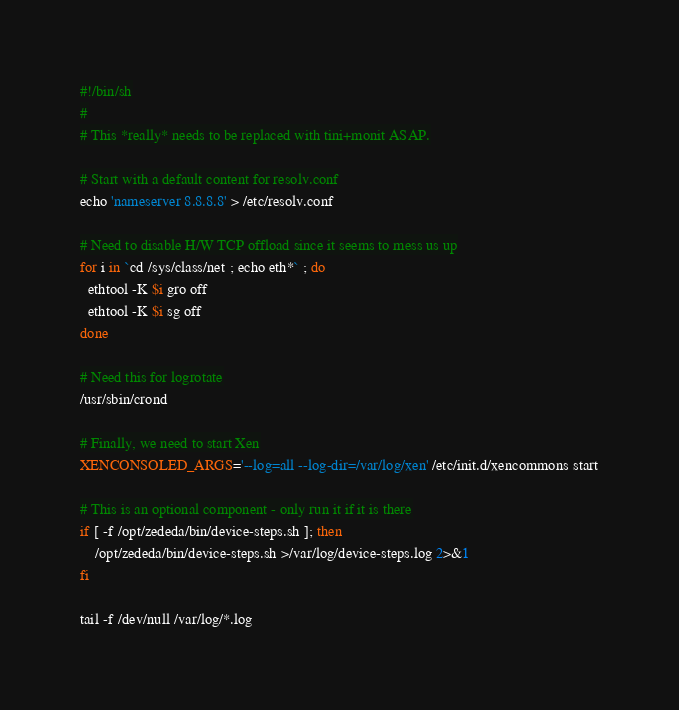<code> <loc_0><loc_0><loc_500><loc_500><_Bash_>#!/bin/sh
#
# This *really* needs to be replaced with tini+monit ASAP.

# Start with a default content for resolv.conf
echo 'nameserver 8.8.8.8' > /etc/resolv.conf

# Need to disable H/W TCP offload since it seems to mess us up
for i in `cd /sys/class/net ; echo eth*` ; do
  ethtool -K $i gro off
  ethtool -K $i sg off
done

# Need this for logrotate
/usr/sbin/crond

# Finally, we need to start Xen
XENCONSOLED_ARGS='--log=all --log-dir=/var/log/xen' /etc/init.d/xencommons start

# This is an optional component - only run it if it is there
if [ -f /opt/zededa/bin/device-steps.sh ]; then
    /opt/zededa/bin/device-steps.sh >/var/log/device-steps.log 2>&1
fi

tail -f /dev/null /var/log/*.log
</code> 